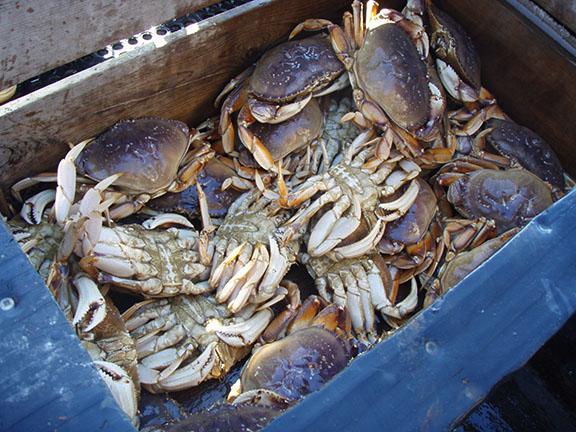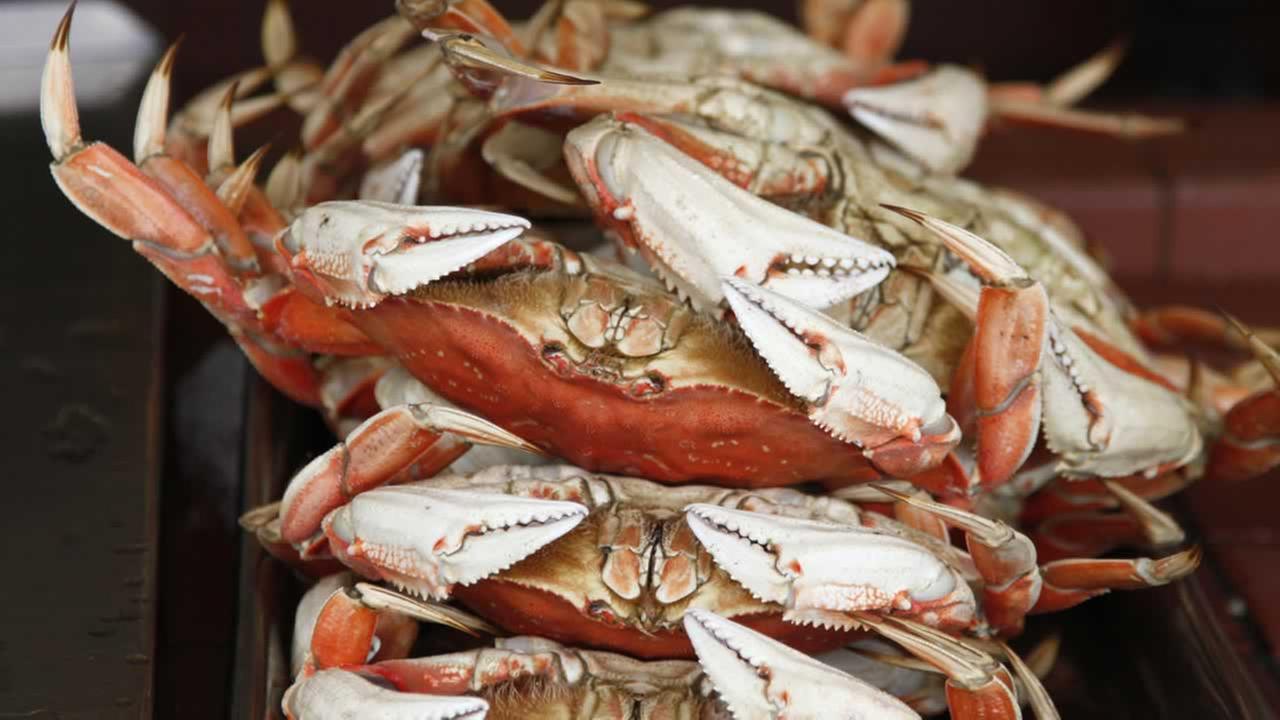The first image is the image on the left, the second image is the image on the right. Assess this claim about the two images: "there are 3 crabs stacked on top of each other, all three are upside down". Correct or not? Answer yes or no. Yes. 